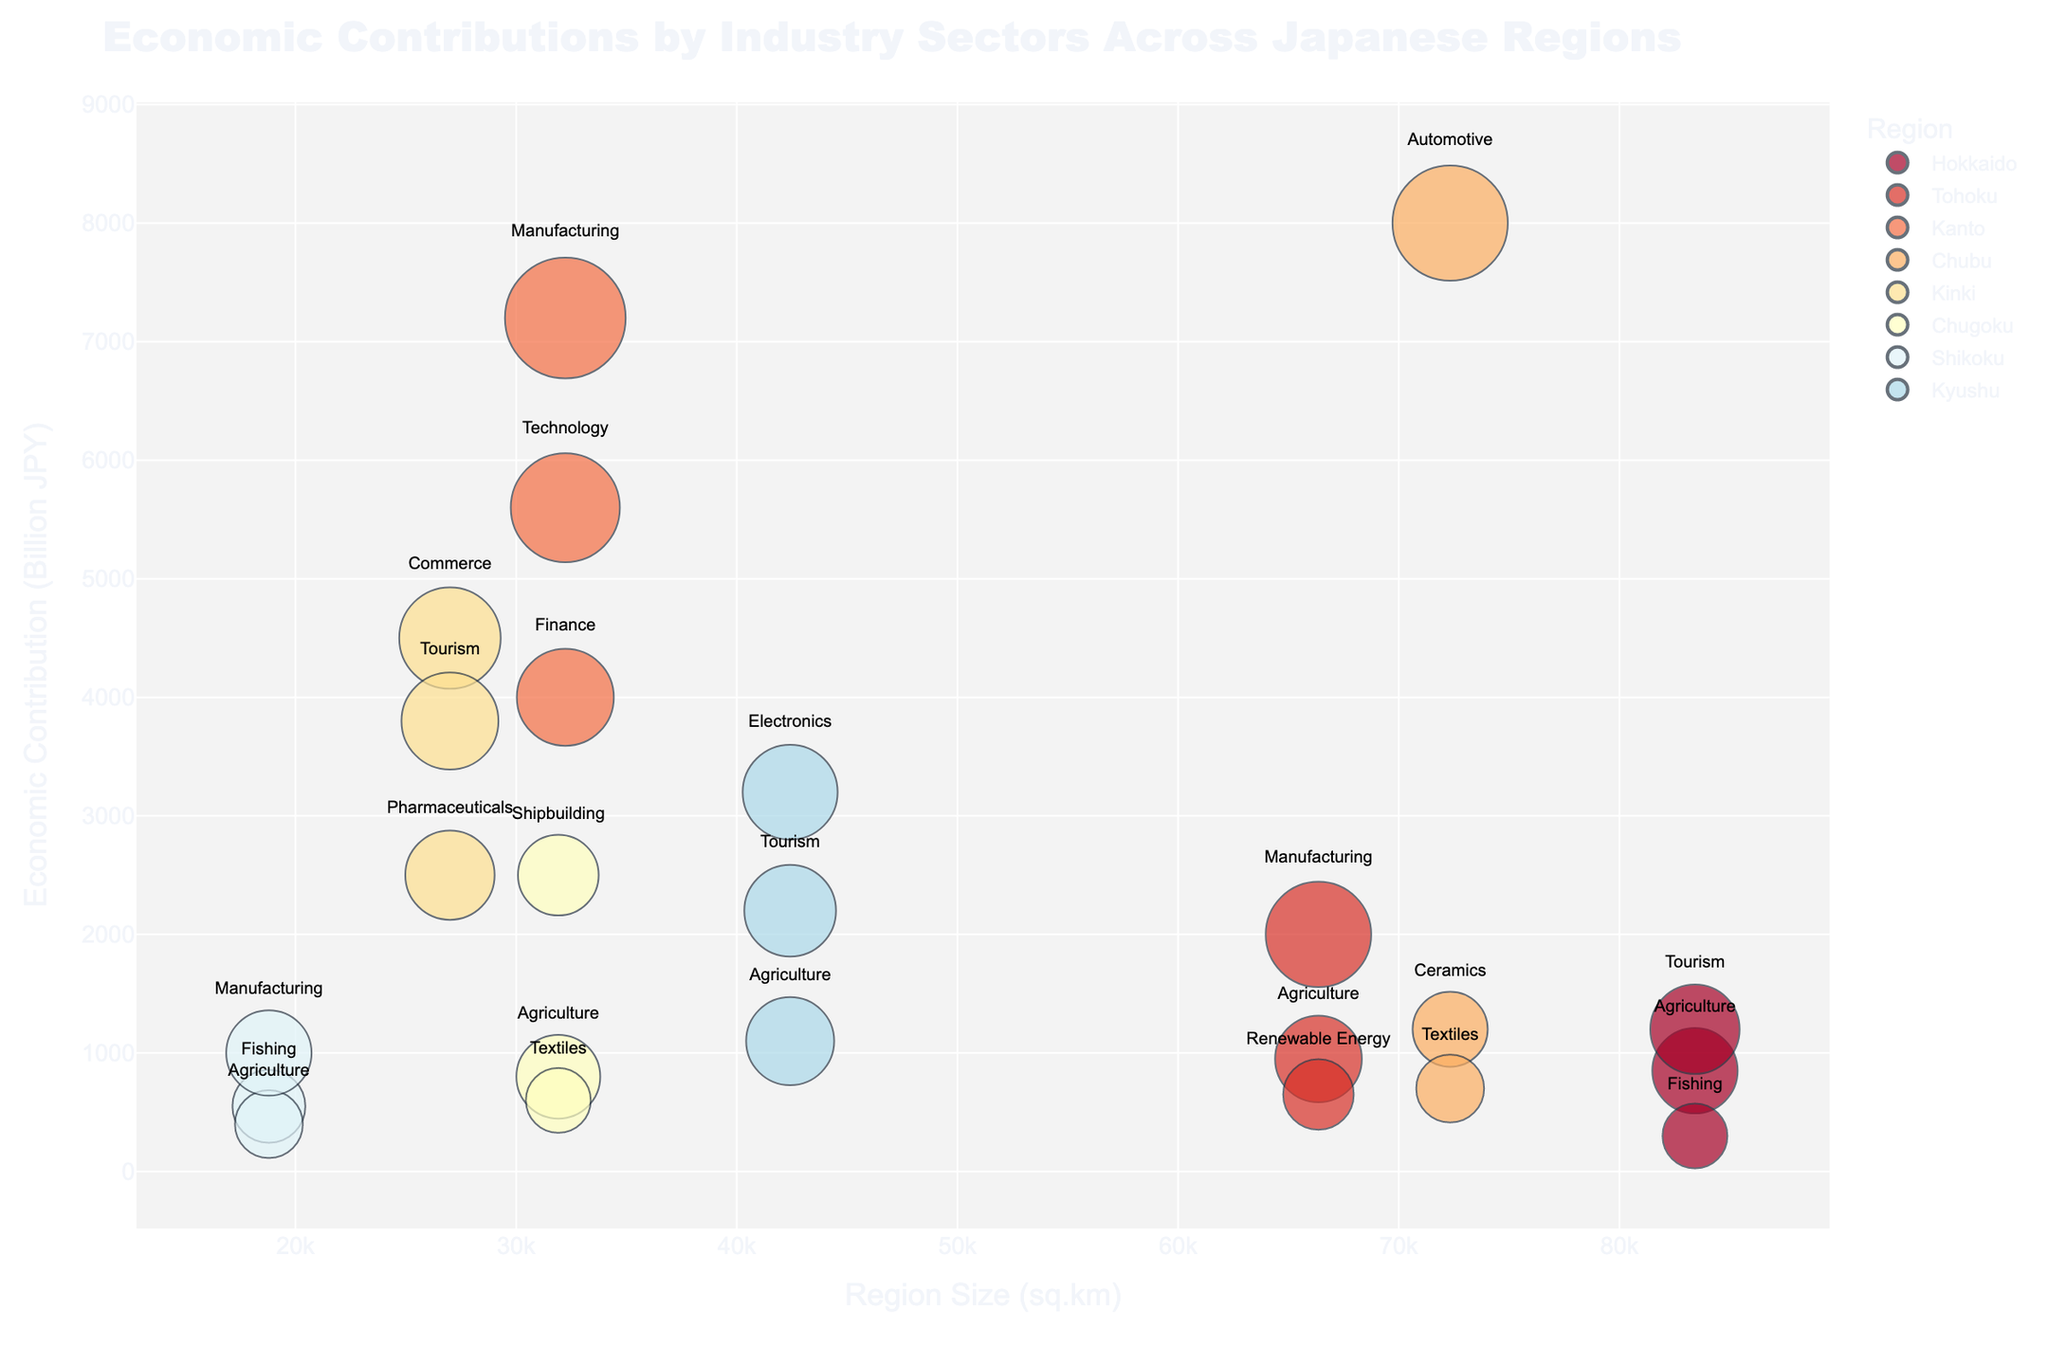What is the title of the bubble chart? The title is located at the top of the chart, which provides a summary of what the visualization represents. In this case, it is "Economic Contributions by Industry Sectors Across Japanese Regions".
Answer: Economic Contributions by Industry Sectors Across Japanese Regions Which region has the highest economic contribution for the Manufacturing sector? First, identify all bubbles with the label "Manufacturing". Then, check the economic contribution on the y-axis for these bubbles. The highest y-axis value among them will indicate the region with the highest contribution.
Answer: Kanto How does the bubble size for Agriculture in Hokkaido compare to Agriculture in Kyushu? Locate the bubbles labeled "Agriculture" in both Hokkaido and Kyushu. Compare the sizes of these bubbles, which corresponds to their respective employment figures. Hokkaido’s bubble is larger, indicating higher employment in the Agriculture sector.
Answer: Hokkaido's bubble is larger Which industry in Chubu has the highest employment? Focus on Chubu region's bubbles and look at their corresponding bubble sizes, which represent employment. The largest bubble size in Chubu indicates the industry with the highest employment.
Answer: Automotive What's the difference in economic contribution between the Technology sector in Kanto and the Electronics sector in Kyushu? Identify the economic contributions for Technology in Kanto and Electronics in Kyushu by checking their positions on the y-axis. Then, subtract the smaller value from the larger one.
Answer: 2400 Billion JPY Which region covers the largest area in terms of its size in sq.km? Check the x-axis labeled "Region Size (sq.km)" and identify the region that is located furthest to the right, indicating the largest area.
Answer: Hokkaido Is the economic contribution of Tourism in Hokkaido greater than that in Kyushu? Locate the bubbles labeled "Tourism" for both Hokkaido and Kyushu. Compare their positions on the y-axis to determine which one has a higher economic contribution.
Answer: No What is the sum of economic contributions from Agriculture sectors across all regions? Find all bubbles labeled "Agriculture" and sum their economic contributions by reading the values on the y-axis for these bubbles. Hokkaido (850) + Tohoku (950) + Chugoku (800) + Shikoku (400) + Kyushu (1100) = 4100 Billion JPY
Answer: 4100 Billion JPY Which industry sector in Tohoku has the smallest bubble size? Within Tohoku, examine the bubbles for different sectors and find the smallest bubble, which indicates the lowest employment.
Answer: Renewable Energy Between Kanto and Chubu, which region has a larger bubble for Manufacturing? Identify the Manufacturing bubbles in both Kanto and Chubu. Compare their sizes to determine which region has a larger bubble, indicating higher employment.
Answer: Kanto 